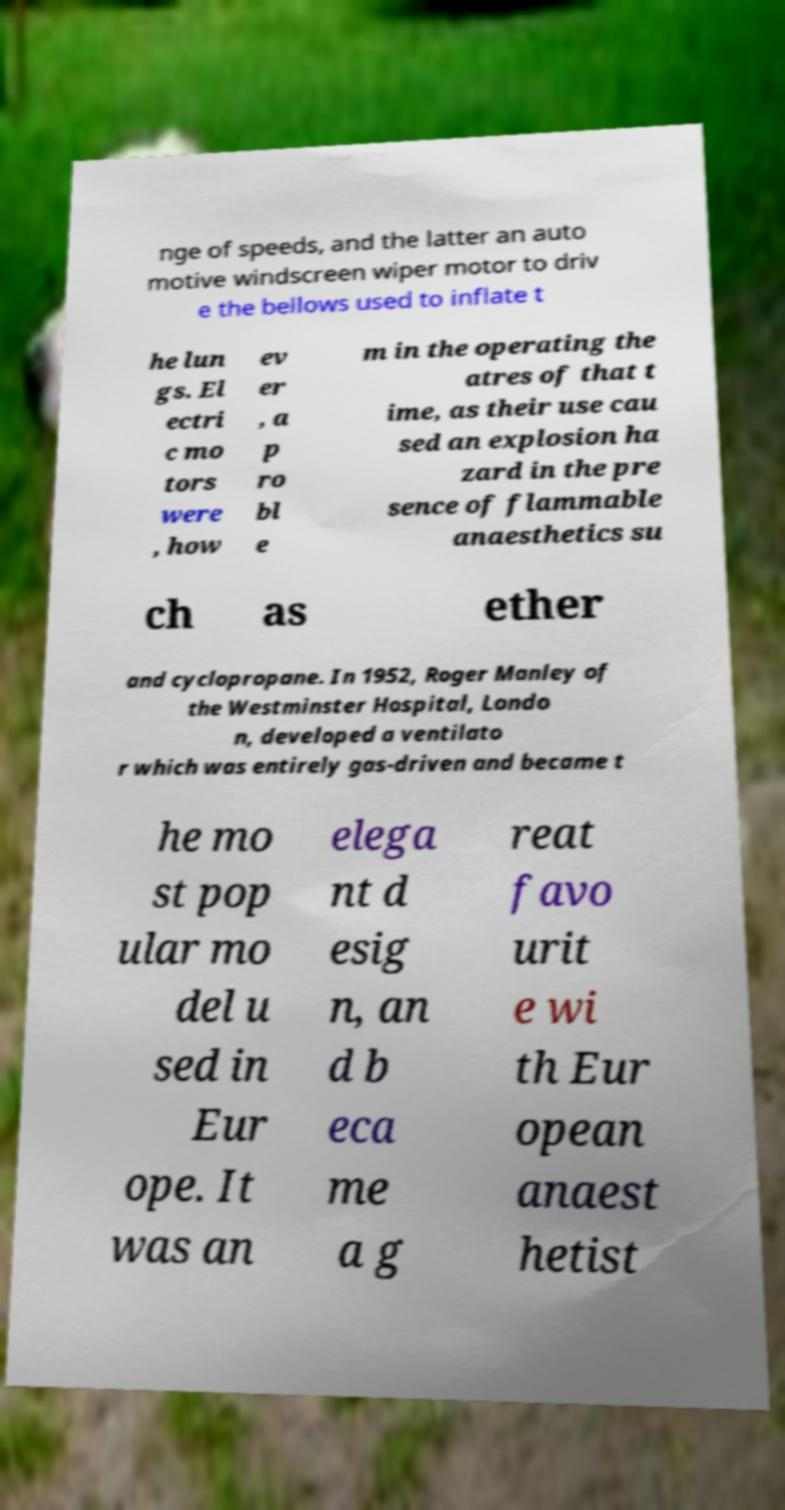Please identify and transcribe the text found in this image. nge of speeds, and the latter an auto motive windscreen wiper motor to driv e the bellows used to inflate t he lun gs. El ectri c mo tors were , how ev er , a p ro bl e m in the operating the atres of that t ime, as their use cau sed an explosion ha zard in the pre sence of flammable anaesthetics su ch as ether and cyclopropane. In 1952, Roger Manley of the Westminster Hospital, Londo n, developed a ventilato r which was entirely gas-driven and became t he mo st pop ular mo del u sed in Eur ope. It was an elega nt d esig n, an d b eca me a g reat favo urit e wi th Eur opean anaest hetist 